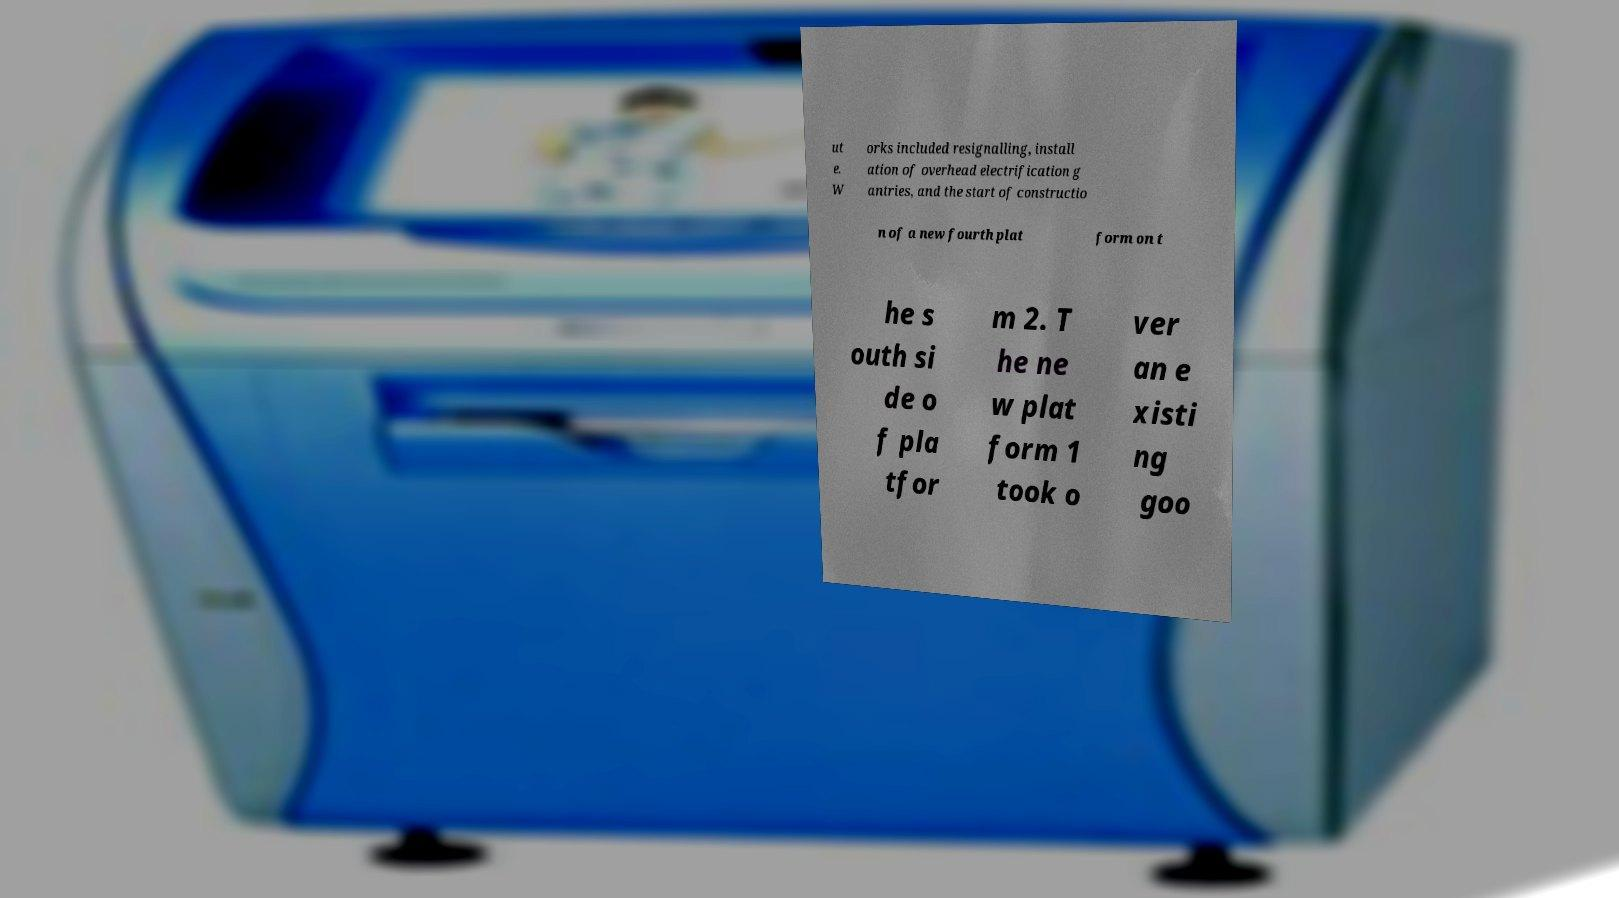Could you extract and type out the text from this image? ut e. W orks included resignalling, install ation of overhead electrification g antries, and the start of constructio n of a new fourth plat form on t he s outh si de o f pla tfor m 2. T he ne w plat form 1 took o ver an e xisti ng goo 